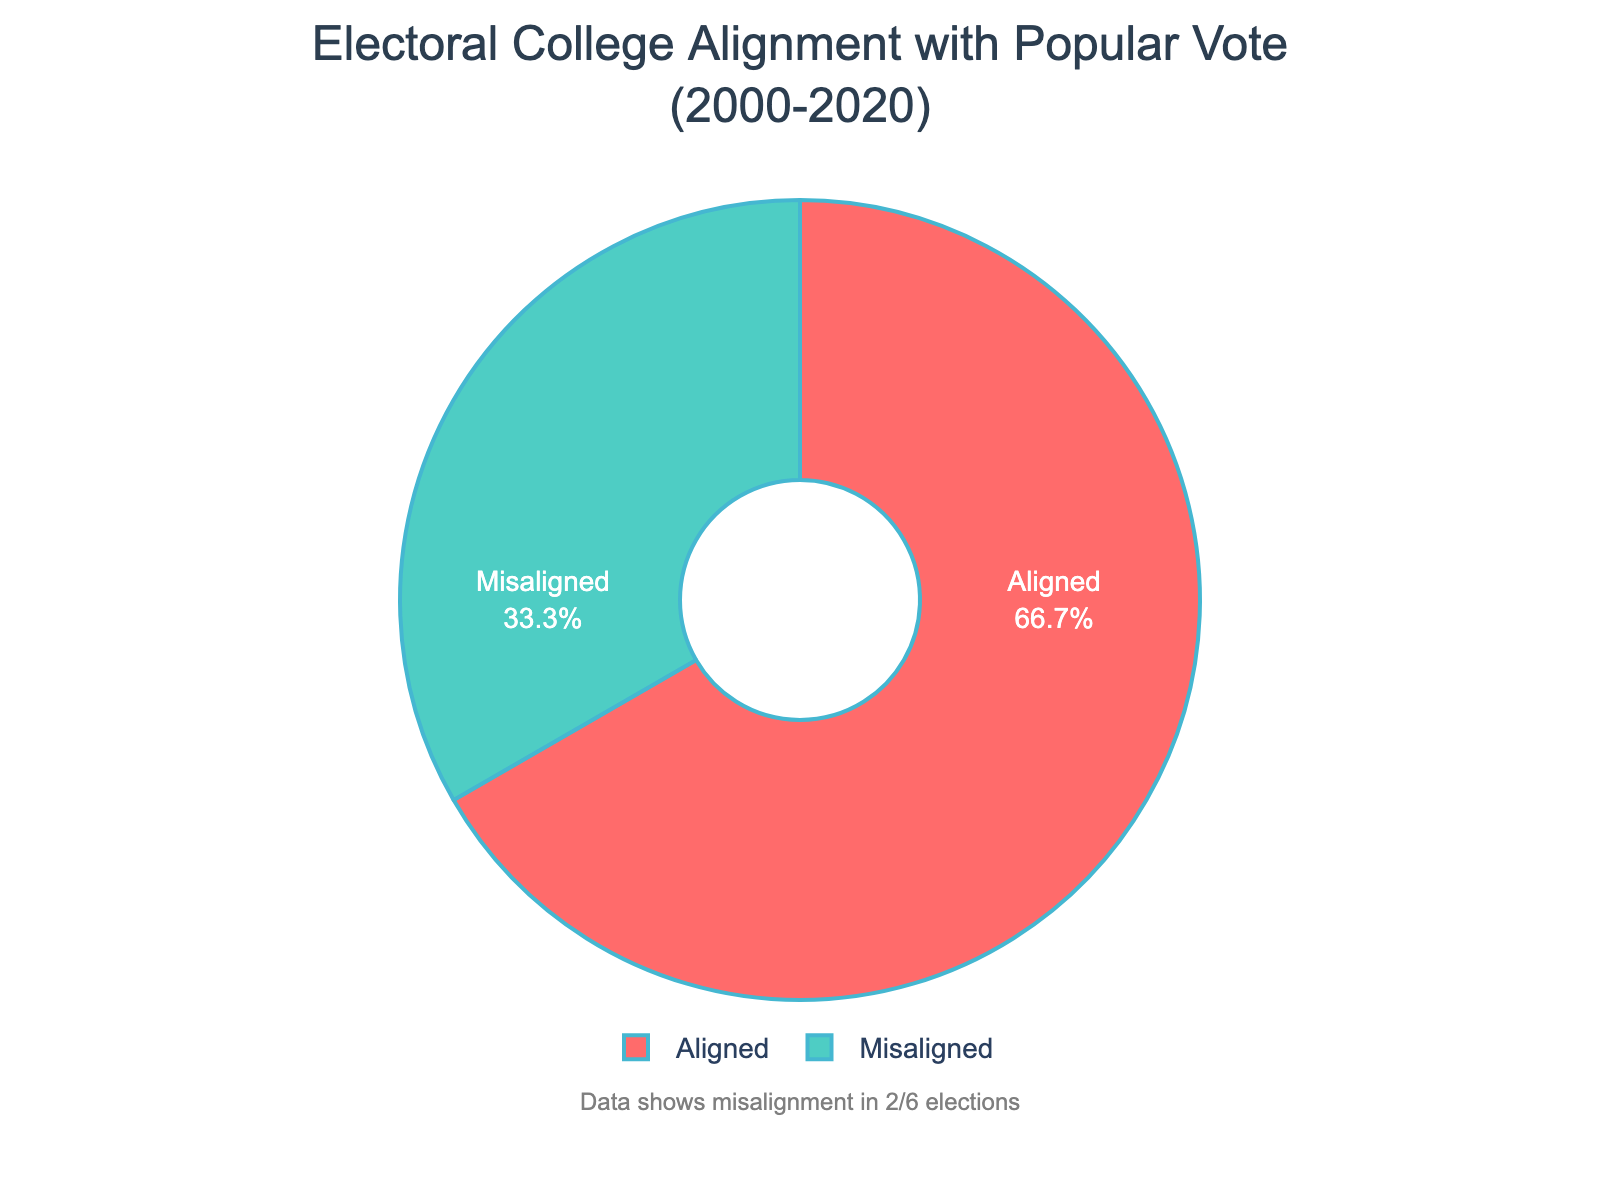Which alignment category is more common in the chart? The pie chart shows two categories: "Aligned" and "Misaligned." By analyzing the proportions, we can see that the "Aligned" category takes up a larger percentage of the pie.
Answer: Aligned How many elections are represented in the "Misaligned" category? The annotation indicates that the data shows misalignment in 2 out of 6 elections. Therefore, the number of elections in the "Misaligned" category is 2.
Answer: 2 What percentage of elections resulted in a misalignment between the popular vote and the Electoral College outcomes? According to the pie chart and the annotation, there are 2 misaligned elections out of a total of 6. The percentage can be calculated as (2/6) * 100 = 33.33%.
Answer: 33.33% Which color represents the "Aligned" category and what is its significance? In the pie chart, "Aligned" is represented by the green color. This signifies that the Electoral College winner was also the popular vote winner in these elections.
Answer: Green Compare the alignment categories in terms of their count. Which category has more elections, and by how many? The chart shows that there are 4 "Aligned" elections and 2 "Misaligned" elections. By subtracting 2 from 4, we see that the "Aligned" category has 2 more elections.
Answer: Aligned by 2 What's the ratio of aligned to misaligned elections in the chart? There are 4 aligned and 2 misaligned elections. Therefore, the ratio of aligned to misaligned elections is 4:2, which simplifies to 2:1.
Answer: 2:1 Determine the average percentage of aligned elections. The pie chart shows 4 out of 6 elections are aligned. The average percentage can be calculated as (4/6) * 100 = 66.67%.
Answer: 66.67% If one more aligned election were added, what would be the new percentage of aligned elections? If one more aligned election is added, there would be 5 aligned elections out of a total of 7. The new percentage can be calculated as (5/7) * 100 ≈ 71.43%.
Answer: 71.43% What is the significance of the hole in the center of the pie chart? The hole in the center of the pie chart signifies that it is a donut chart, which is often used to show proportions of categories within a whole while focusing attention on the relative sizes of slices.
Answer: Donut chart significance 